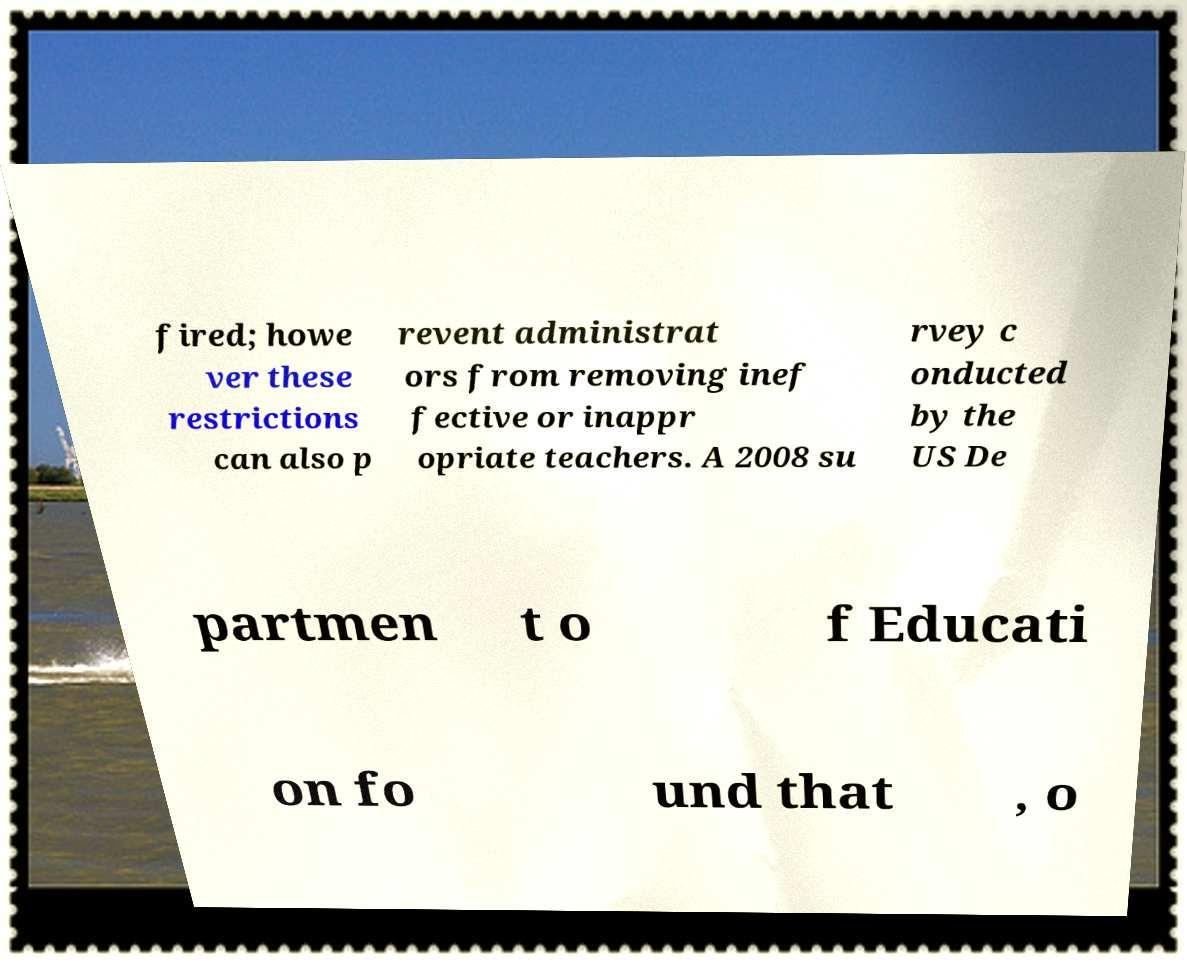Could you assist in decoding the text presented in this image and type it out clearly? fired; howe ver these restrictions can also p revent administrat ors from removing inef fective or inappr opriate teachers. A 2008 su rvey c onducted by the US De partmen t o f Educati on fo und that , o 